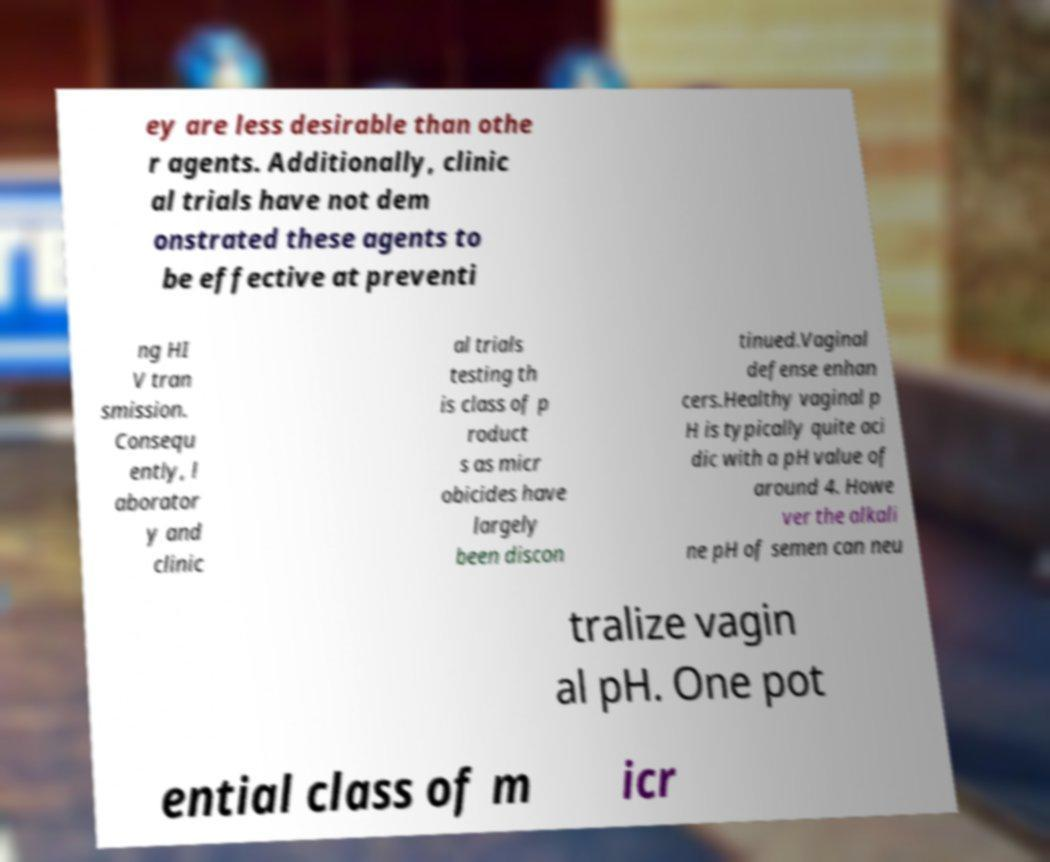What messages or text are displayed in this image? I need them in a readable, typed format. ey are less desirable than othe r agents. Additionally, clinic al trials have not dem onstrated these agents to be effective at preventi ng HI V tran smission. Consequ ently, l aborator y and clinic al trials testing th is class of p roduct s as micr obicides have largely been discon tinued.Vaginal defense enhan cers.Healthy vaginal p H is typically quite aci dic with a pH value of around 4. Howe ver the alkali ne pH of semen can neu tralize vagin al pH. One pot ential class of m icr 